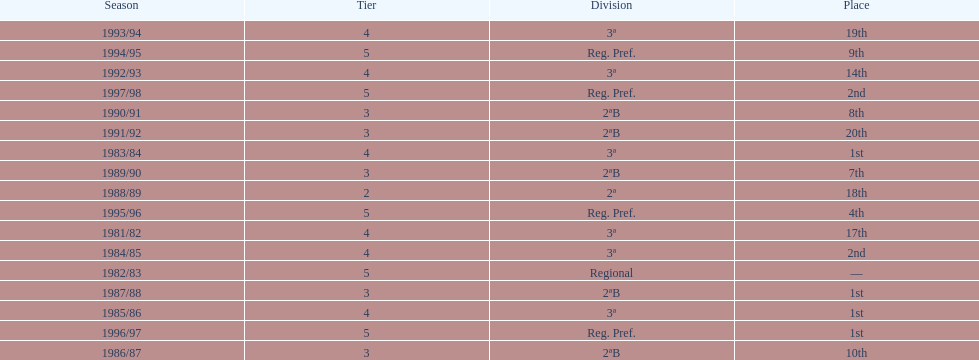In which year did the team have its worst season? 1991/92. 